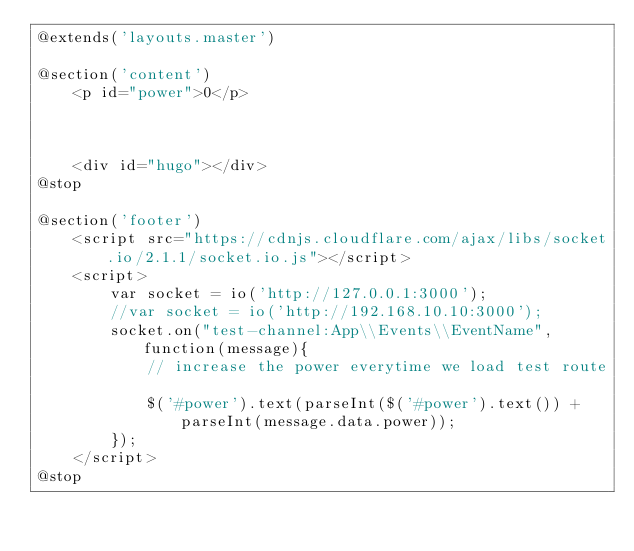<code> <loc_0><loc_0><loc_500><loc_500><_PHP_>@extends('layouts.master')

@section('content')
    <p id="power">0</p>



    <div id="hugo"></div>
@stop

@section('footer')
    <script src="https://cdnjs.cloudflare.com/ajax/libs/socket.io/2.1.1/socket.io.js"></script>
    <script>
        var socket = io('http://127.0.0.1:3000');
        //var socket = io('http://192.168.10.10:3000');
        socket.on("test-channel:App\\Events\\EventName", function(message){
            // increase the power everytime we load test route
            
            $('#power').text(parseInt($('#power').text()) + parseInt(message.data.power));
        });
    </script>
@stop
</code> 